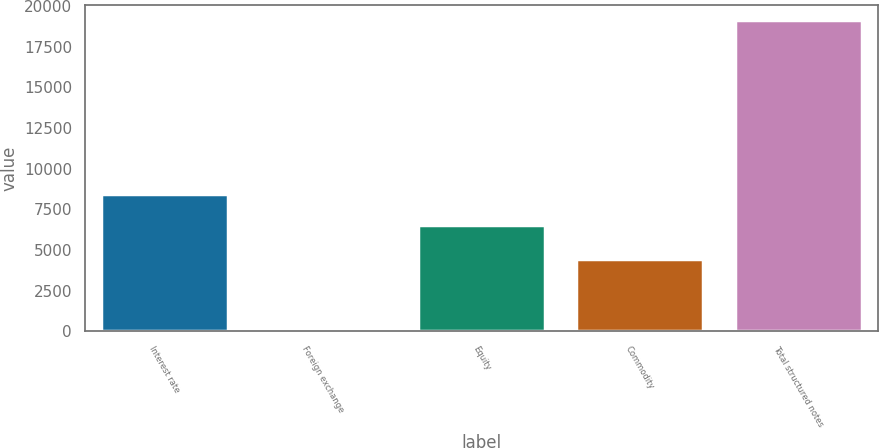<chart> <loc_0><loc_0><loc_500><loc_500><bar_chart><fcel>Interest rate<fcel>Foreign exchange<fcel>Equity<fcel>Commodity<fcel>Total structured notes<nl><fcel>8455.4<fcel>38<fcel>6548<fcel>4468<fcel>19112<nl></chart> 